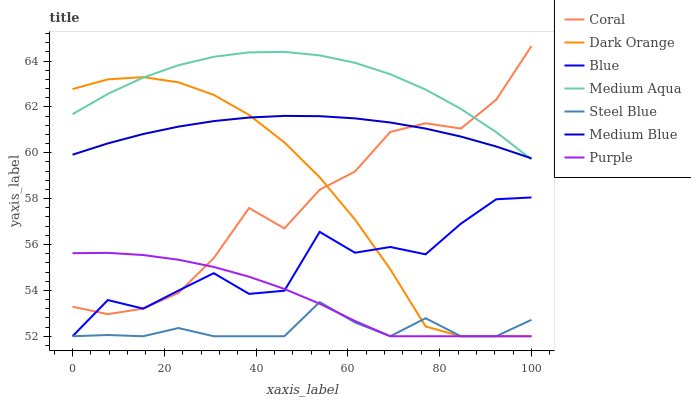Does Steel Blue have the minimum area under the curve?
Answer yes or no. Yes. Does Medium Aqua have the maximum area under the curve?
Answer yes or no. Yes. Does Dark Orange have the minimum area under the curve?
Answer yes or no. No. Does Dark Orange have the maximum area under the curve?
Answer yes or no. No. Is Medium Blue the smoothest?
Answer yes or no. Yes. Is Blue the roughest?
Answer yes or no. Yes. Is Dark Orange the smoothest?
Answer yes or no. No. Is Dark Orange the roughest?
Answer yes or no. No. Does Blue have the lowest value?
Answer yes or no. Yes. Does Coral have the lowest value?
Answer yes or no. No. Does Coral have the highest value?
Answer yes or no. Yes. Does Dark Orange have the highest value?
Answer yes or no. No. Is Steel Blue less than Medium Blue?
Answer yes or no. Yes. Is Medium Blue greater than Steel Blue?
Answer yes or no. Yes. Does Steel Blue intersect Purple?
Answer yes or no. Yes. Is Steel Blue less than Purple?
Answer yes or no. No. Is Steel Blue greater than Purple?
Answer yes or no. No. Does Steel Blue intersect Medium Blue?
Answer yes or no. No. 